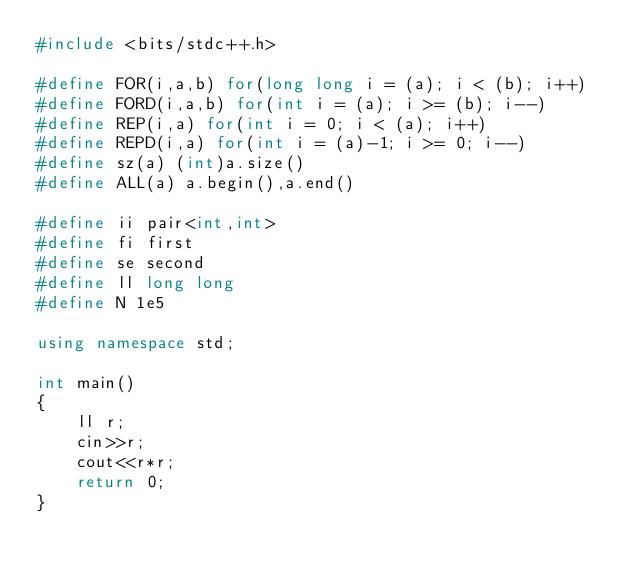<code> <loc_0><loc_0><loc_500><loc_500><_C++_>#include <bits/stdc++.h>

#define FOR(i,a,b) for(long long i = (a); i < (b); i++)
#define FORD(i,a,b) for(int i = (a); i >= (b); i--)
#define REP(i,a) for(int i = 0; i < (a); i++)
#define REPD(i,a) for(int i = (a)-1; i >= 0; i--)
#define sz(a) (int)a.size()
#define ALL(a) a.begin(),a.end()

#define ii pair<int,int>
#define fi first
#define se second
#define ll long long
#define N 1e5

using namespace std;

int main()
{
    ll r;
    cin>>r;
    cout<<r*r;
    return 0;
}
</code> 